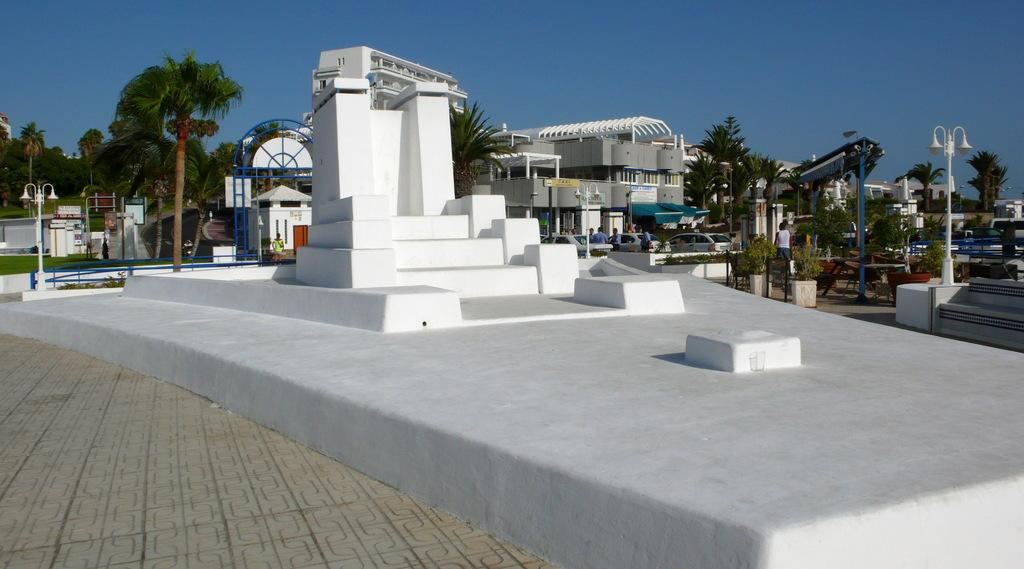What type of surface is present in the image? There is a limestone surface in the image. What is on the limestone surface? There is a sculpture on the limestone surface. What other objects can be seen in the image? There are poles, trees, vehicles, people, and buildings visible in the image. What is visible in the background of the image? The sky is visible in the image. What is the name of the scene depicted in the image? The image does not depict a specific scene with a name. What type of test is being conducted in the image? There is no test being conducted in the image; it features a limestone surface with a sculpture and various other objects and elements. 